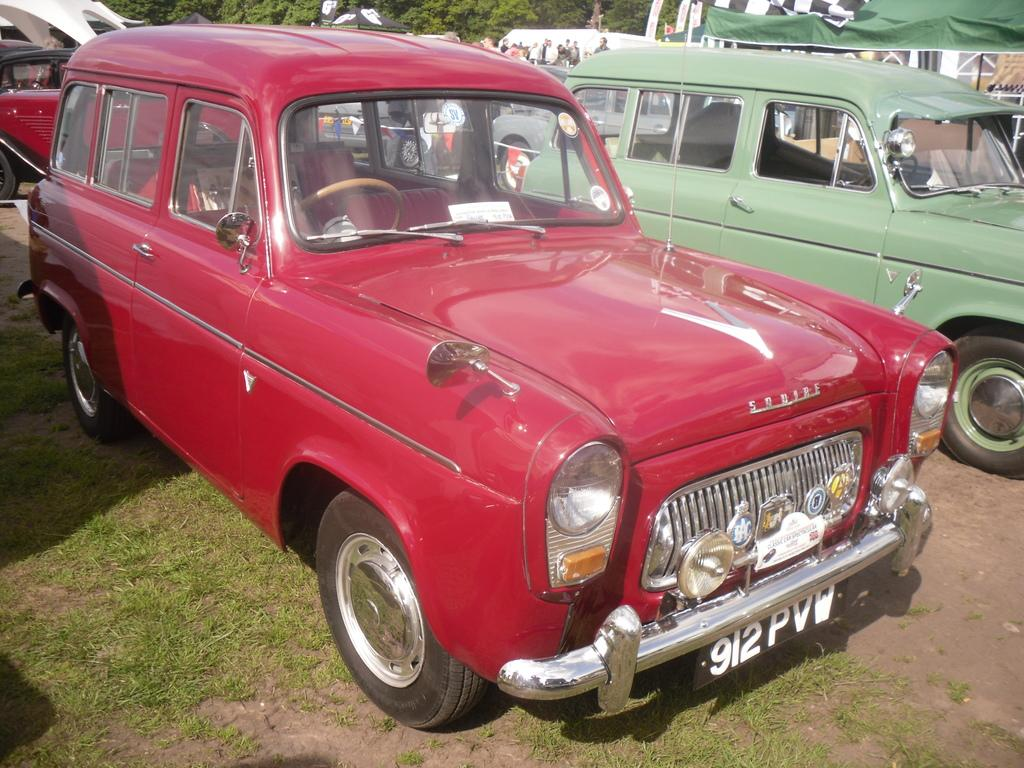What is the primary subject of the image? The primary subject of the image is many cars. Can you describe one of the cars in the image? One of the cars is red. What can be seen in the background of the image? There is a shed and trees in the background of the image. What is the color of the trees in the image? The trees are green. What type of instrument is being played by the army in the image? There is no army or instrument present in the image; it features many cars and a background with a shed and green trees. 